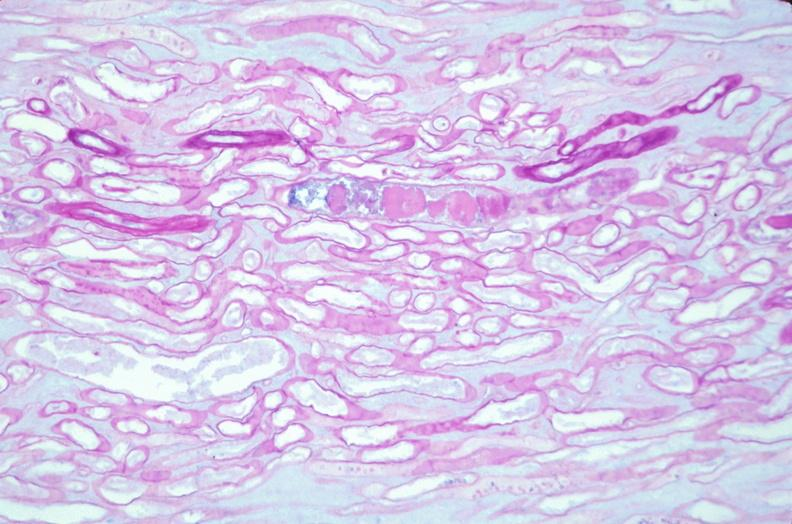does this image show kidney, thickened and hyalinized basement membranes due to diabetes mellitus, pas?
Answer the question using a single word or phrase. Yes 